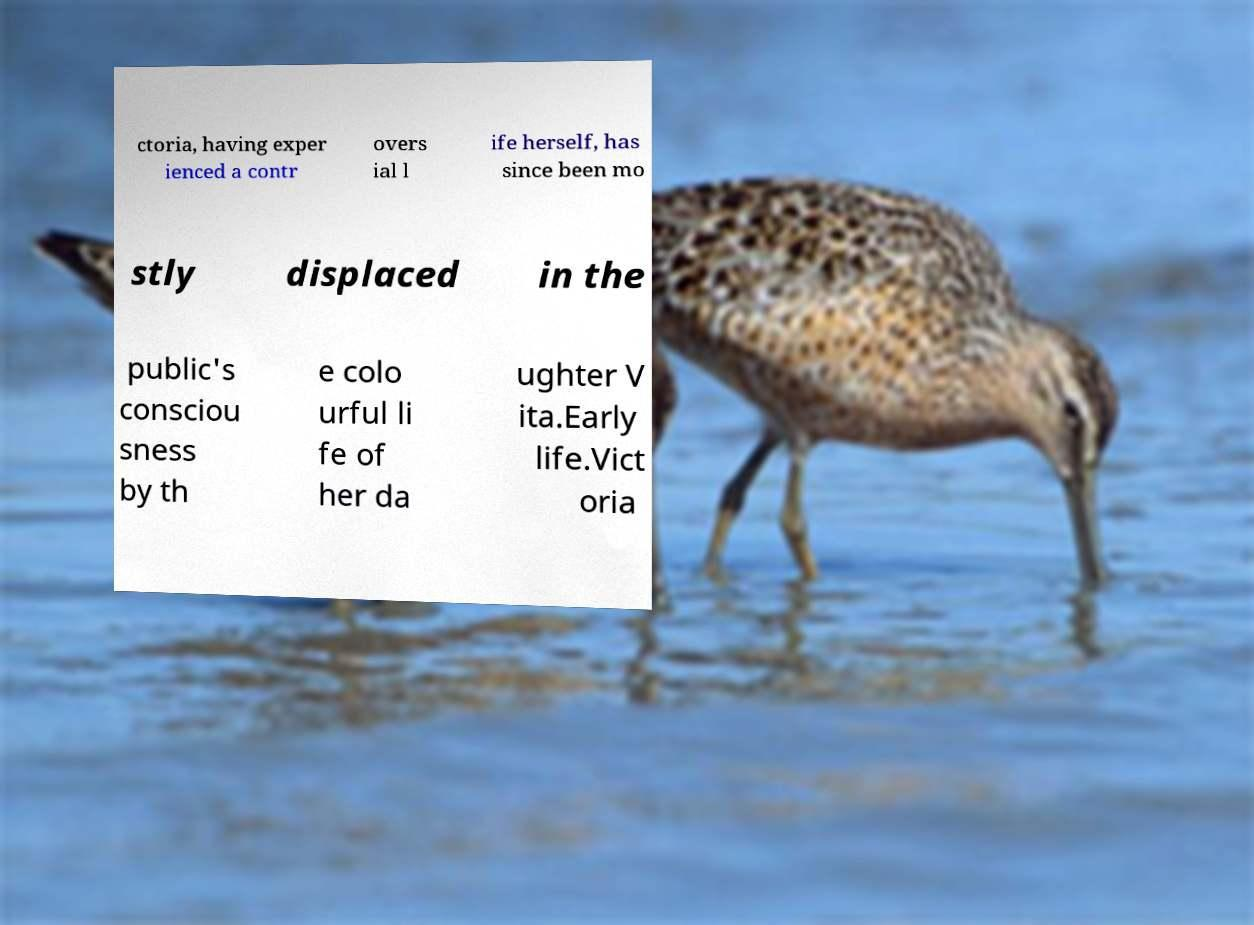Please read and relay the text visible in this image. What does it say? ctoria, having exper ienced a contr overs ial l ife herself, has since been mo stly displaced in the public's consciou sness by th e colo urful li fe of her da ughter V ita.Early life.Vict oria 